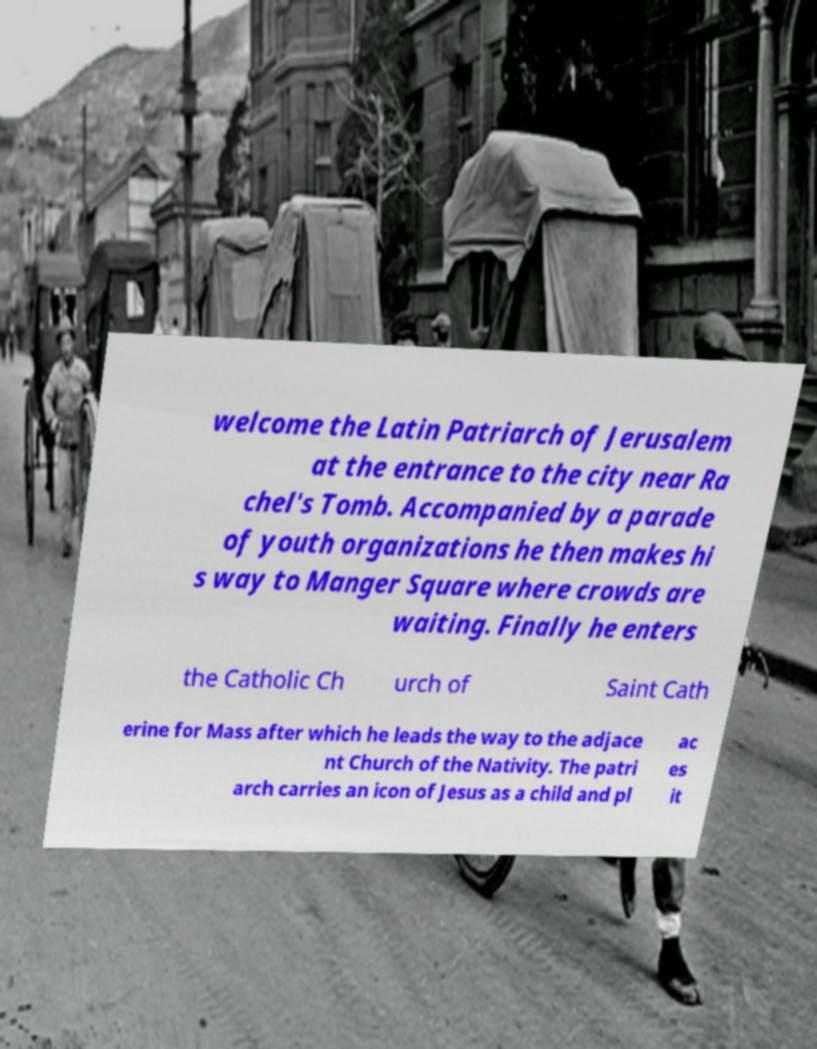Can you read and provide the text displayed in the image?This photo seems to have some interesting text. Can you extract and type it out for me? welcome the Latin Patriarch of Jerusalem at the entrance to the city near Ra chel's Tomb. Accompanied by a parade of youth organizations he then makes hi s way to Manger Square where crowds are waiting. Finally he enters the Catholic Ch urch of Saint Cath erine for Mass after which he leads the way to the adjace nt Church of the Nativity. The patri arch carries an icon of Jesus as a child and pl ac es it 